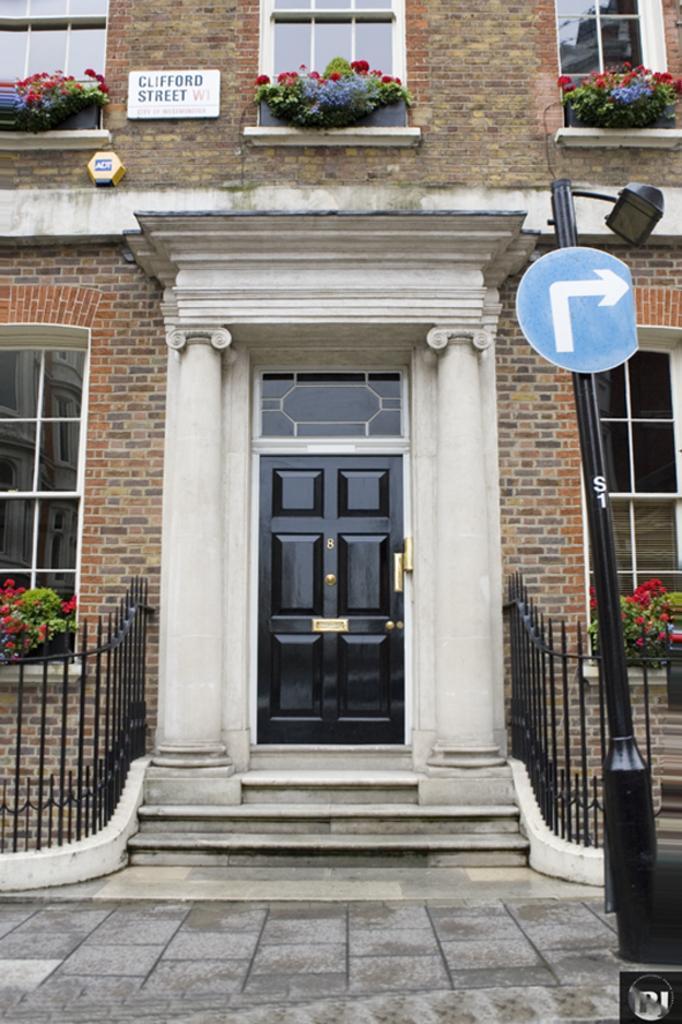In one or two sentences, can you explain what this image depicts? This image is taken outdoors. At the bottom of the image there is a floor. In the middle of the image there is a building with walls, windows and a door. There are a few railings and plants in the pots. On the right side of the image there is a pole with a signboard. 